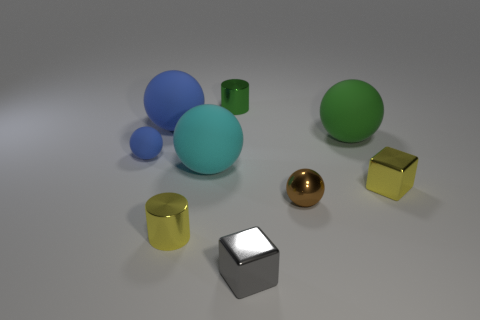What is the size of the brown ball?
Your response must be concise. Small. What number of blocks are tiny yellow objects or tiny objects?
Provide a short and direct response. 2. The cyan rubber thing that is the same shape as the big green rubber object is what size?
Give a very brief answer. Large. How many green cylinders are there?
Provide a succinct answer. 1. There is a tiny blue matte thing; is its shape the same as the metallic object that is right of the green matte sphere?
Offer a very short reply. No. How big is the yellow thing left of the big green matte object?
Give a very brief answer. Small. What is the material of the green sphere?
Offer a very short reply. Rubber. There is a yellow metallic object left of the gray shiny thing; does it have the same shape as the tiny green thing?
Your answer should be compact. Yes. Is there a yellow cylinder that has the same size as the gray metal thing?
Ensure brevity in your answer.  Yes. There is a large rubber sphere on the right side of the object behind the big blue thing; are there any objects behind it?
Offer a terse response. Yes. 